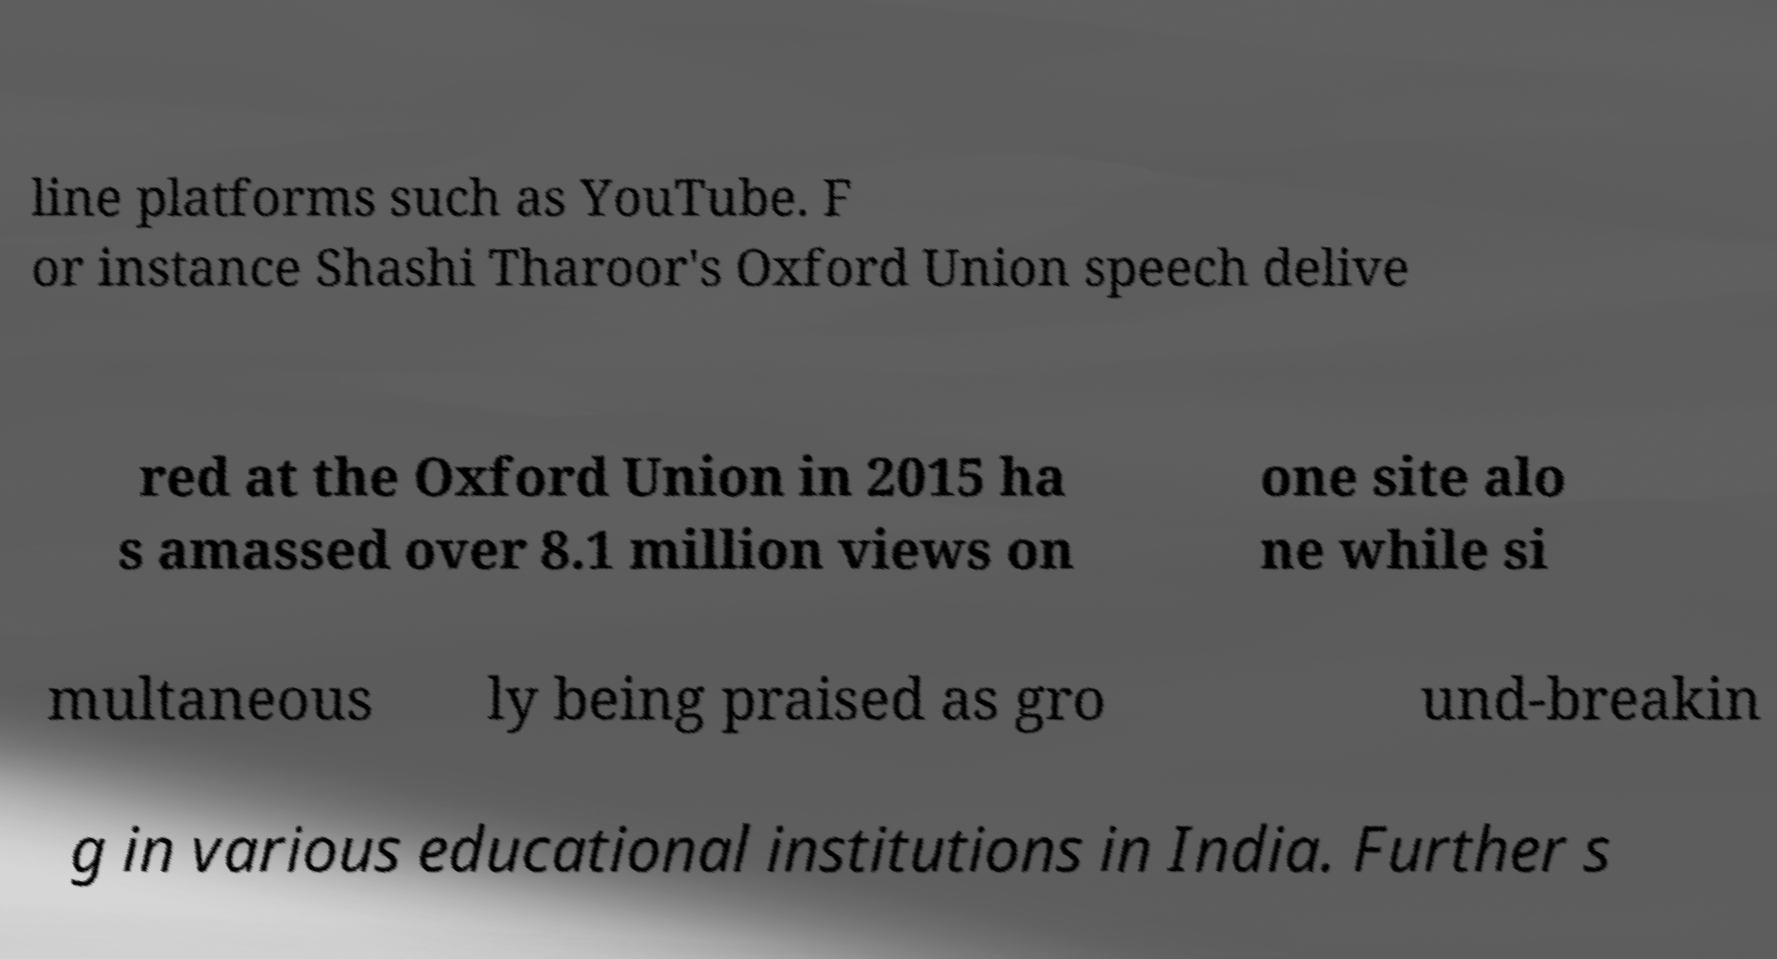Please identify and transcribe the text found in this image. line platforms such as YouTube. F or instance Shashi Tharoor's Oxford Union speech delive red at the Oxford Union in 2015 ha s amassed over 8.1 million views on one site alo ne while si multaneous ly being praised as gro und-breakin g in various educational institutions in India. Further s 